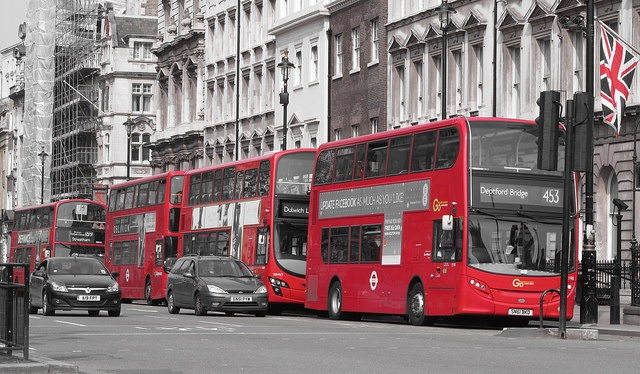Describe the objects in this image and their specific colors. I can see bus in lightgray, gray, black, brown, and darkgray tones, bus in lightgray, gray, black, darkgray, and brown tones, bus in lightgray, gray, brown, black, and darkgray tones, bus in lightgray, gray, black, darkgray, and brown tones, and car in lightgray, gray, black, and darkgray tones in this image. 